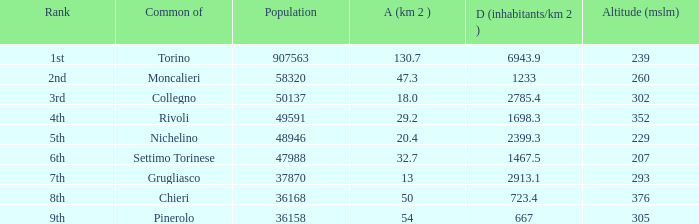What is the density of the common with an area of 20.4 km^2? 2399.3. 